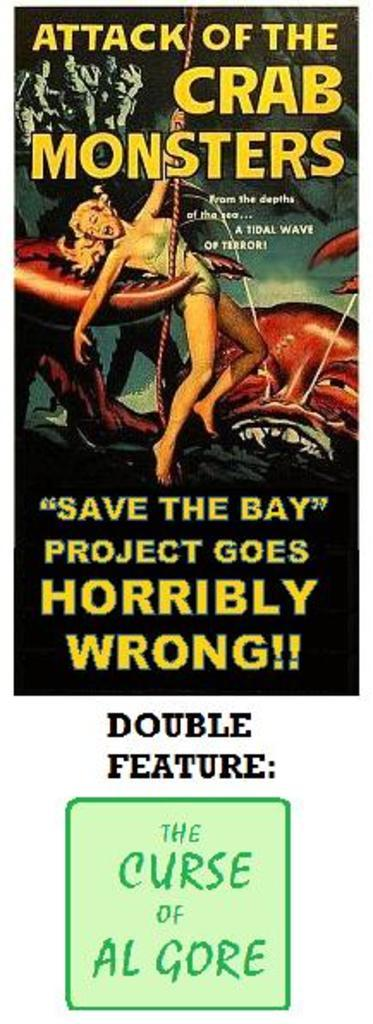<image>
Relay a brief, clear account of the picture shown. Poster with an alien grabbing a woman titled "Attack of the Crab Monsters". 